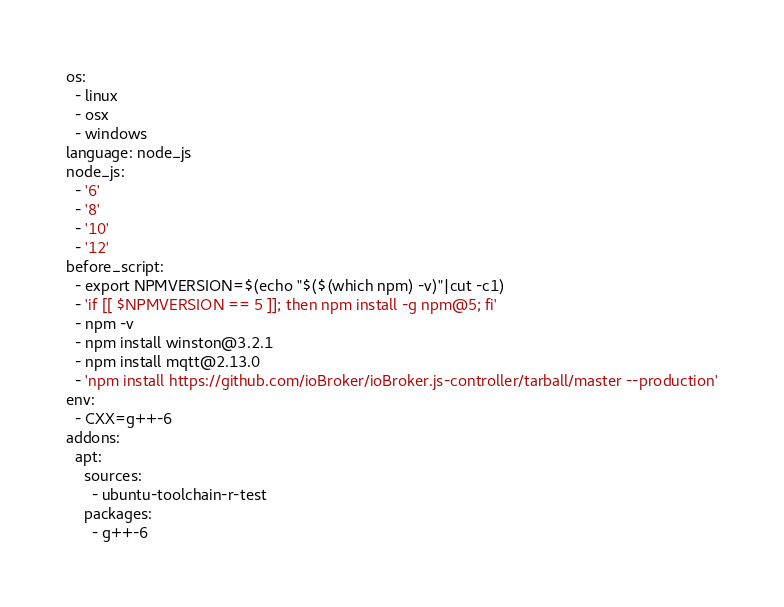<code> <loc_0><loc_0><loc_500><loc_500><_YAML_>os:
  - linux
  - osx
  - windows
language: node_js
node_js:
  - '6'
  - '8'
  - '10'
  - '12'
before_script:
  - export NPMVERSION=$(echo "$($(which npm) -v)"|cut -c1)
  - 'if [[ $NPMVERSION == 5 ]]; then npm install -g npm@5; fi'
  - npm -v
  - npm install winston@3.2.1
  - npm install mqtt@2.13.0
  - 'npm install https://github.com/ioBroker/ioBroker.js-controller/tarball/master --production'
env:
  - CXX=g++-6
addons:
  apt:
    sources:
      - ubuntu-toolchain-r-test
    packages:
      - g++-6
</code> 